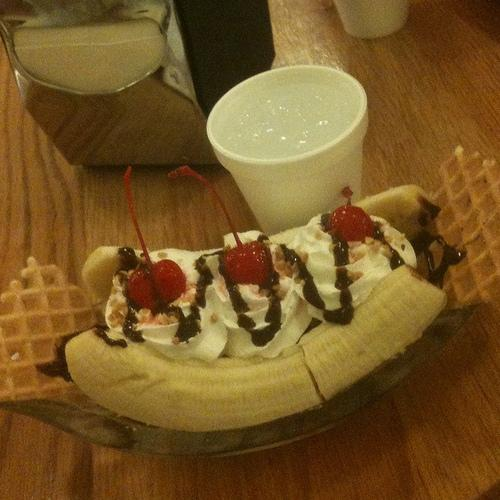Analyze the mood or atmosphere of the image based on its elements. The image portrays a pleasant, indulgent atmosphere with the delicious banana split dessert, a refreshing drink on a wooden table, and the neatness of the silver napkin holder with white napkins. Provide a detailed description of the cherry in the image. The cherry is red with a small stem and is positioned on top of the whipped cream on the banana split. What elements in the image communicate a sense of coldness or chill? The crushed ice and water in the styrofoam cup and the ice cream in the banana split communicate a sense of coldness or chill. Mention any unique accessories found on the wooden table. A chrome and black napkin dispenser with white paper napkins inside is a unique accessory found on the wooden table. Describe the table setting in the image. The table setting includes a banana split in a clear bowl, a white styrofoam cup of drink, and a silver napkin holder with white paper napkins on a wooden surface. What kind of container is holding the clear drink in the image? A white styrofoam cup is holding the clear drink. List the types of toppings on the banana split in the image. Whipped cream, chocolate syrup, nuts, and cherries are the toppings on the banana split. How is the ice cream in the image presented? The ice cream is presented as a banana split with three scoops of ice cream, whipped cream with chocolate syrup, nuts, and cherries on top, placed on a waffle cone. Identify the dessert in the image along with its key components. A banana split with whip cream, chocolate syrup, nuts, waffle cone, and three cherries on top is the dessert in the image. What type of drink is in the white cup? The white cup contains ice water. Describe the attributes of the cherries. Red in color, small stems, round shape, and glossy texture. Is the image focused primarily on a dessert or a beverage? Dessert - banana split. Examine the interaction between the styrofoam cup and the wooden table. The styrofoam cup is placed on the wooden table. Identify the ice cream cone type in the banana split. Waffle ice cream cone. Which object is most likely the coldest? Styrofoam cup of water with ice. Rate the image quality on a scale of 1 to 10. 8 - clear and well-composed but could be brighter. Does the wooden table have a blue tablecloth on it? There is no mention of a tablecloth, only a wooden table and wooden surface are mentioned, implying it's uncovered. Analyze the interaction between the ice cream sundae and the waffle cone pieces. The waffle cone pieces are used as decorative and edible elements in the ice cream sundae. Do the napkins appear to be clean? Yes, white paper napkins inside the napkin holder appear clean. Is there a green cherry on the banana split? There is no mention of a green cherry in the image, only red cherries are mentioned multiple times. Is there a slice of orange next to the banana slice in the ice cream? No, it's not mentioned in the image. What is the overall sentiment of the image? Positive - as it depicts a delicious dessert. Where are the peanuts located? On top of the banana split. Are the banana slices visible? Yes, the long banana slice in ice cream is visible. Determine if there is any text in the image. No text present. Describe the main subject of the image. A banana ice cream sundae with whipped cream, chocolate sauce, nuts, waffle cone pieces, and three cherries on top. How many cherries are on the banana split? Three cherries. Can you find the blue napkin in the silver napkin holder? There is no mention of a blue napkin, only white paper napkins inside the mouth of the dispenser are mentioned. Identify any unusual or unexpected objects in the image. No unexpected or unusual objects. Translate the visual information into a meaningful sentence describing the main objects. A tasty banana split is served in a clear dish atop a wooden table, accompanied by a cold cup of water with ice. Is there a strawberry ice cream scoop in the banana split? There is no mention of a strawberry ice cream scoop or any specific ice cream flavors, only three scoops of ice cream are mentioned. What type of cup is holding the liquid? White styrofoam cup. List all the objects present in the image. Banana split, whipped cream, chocolate sauce, nuts, waffle cone pieces, cherries, clear ice cream dish, styrofoam cup of water, wooden table, silver napkin holder, waffle chips, white paper napkins. 